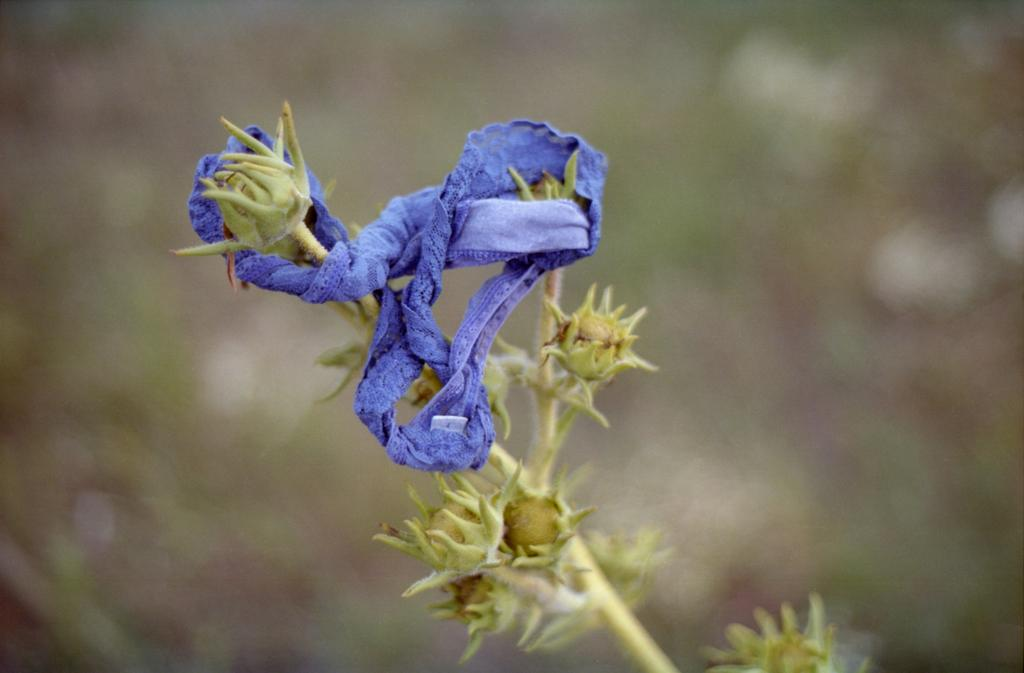What is present in the image? There is a plant in the image. What is covering the plant? There is a cloth on the plant. Can you describe the background of the image? The background of the image is blurred. How many children are playing near the oven in the image? There are no children or ovens present in the image. The image only features a plant with a cloth on it, and the background is blurred. 